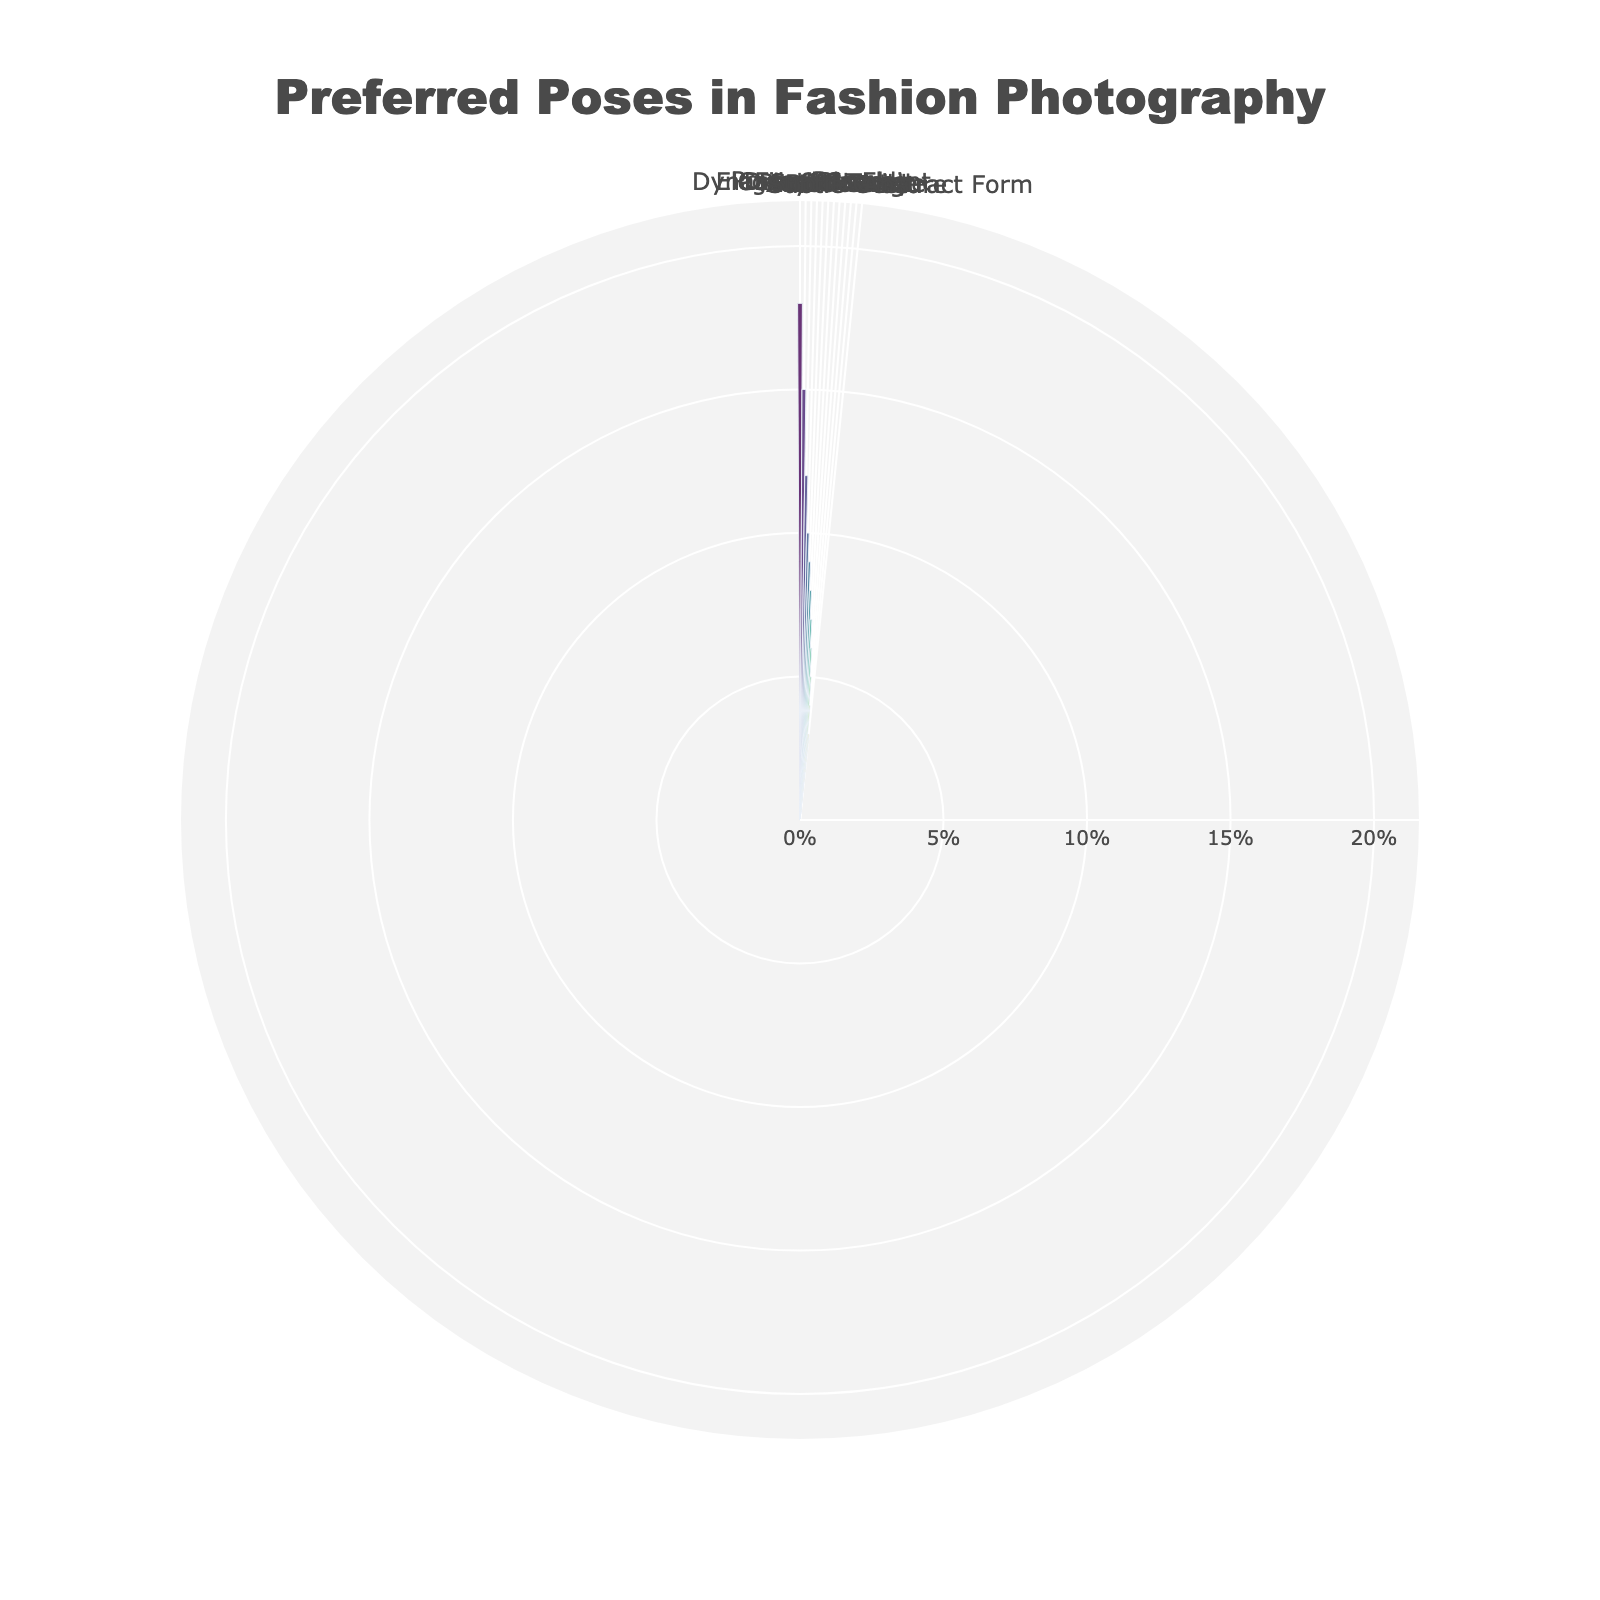Which pose has the highest preference in fashion photography? The figure shows the percentage values of different poses, with "Power Pose" having the highest value at 18%.
Answer: Power Pose What is the total percentage of poses categorized as "artistic" and "abstract"? The "Artistic Angle" has a percentage of 5%, and "Abstract Form" has a percentage of 3%. Summing them up gives 5% + 3% = 8%.
Answer: 8% How does the preference for "Elegant Glance" compare to "Soft Beauty"? The percentages for "Elegant Glance" and "Soft Beauty" are 15% and 6%, respectively. "Elegant Glance" is higher with a difference of 15% - 6% = 9%.
Answer: Elegant Glance Which pose category has the lowest preference, and what is its percentage? The figure shows that "Subtle Gesture" and "Abstract Form" are both at the lowest percentage of 3%.
Answer: Subtle Gesture and Abstract Form What is the average percentage of the four least preferred poses? The four least preferred poses are "Bold Stride" (4%), "Subtle Gesture" (3%), "Abstract Form" (3%), and "Artistic Angle" (5%). Sum them up to get 4% + 3% + 3% + 5% = 15%, and then divide by 4 to get the average, 15% / 4 = 3.75%.
Answer: 3.75% Which pose is preferred almost twice as much as "Bold Stride"? The percentage for "Bold Stride" is 4%. "Elegant Glance" has a percentage of 15%, which is almost four times more, and "Dynamic Movement" has a percentage of 12%, which is three times more. "Casual Stand" has a percentage of 10%, which is about twice as much as 4%.
Answer: Casual Stand How do "Dynamic Movement" and "Playful Twist" together compare with "Power Pose"? "Dynamic Movement" has a percentage of 12%, and "Playful Twist" has a percentage of 7%. Adding them together results in 12% + 7% = 19%. "Power Pose" stands at 18%, so together they are slightly higher.
Answer: 19% vs 18% What is the median percentage value of all the poses? To find the median, order the poses by percentage: 3%, 3%, 4%, 5%, 6%, 7%, 8%, 9%, 10%, 12%, 15%, 18%. The middle values are 7% and 8%, so the median is (7% + 8%) / 2 = 7.5%.
Answer: 7.5% Which pose categories make up more than 50% of the total preference in fashion photography? Adding up the percentages from highest to determine where we surpass 50%: "Power Pose" (18%), "Elegant Glance" (15%), "Dynamic Movement" (12%), and "Casual Stand" (10%). Their cumulative percentage is 55%.
Answer: Power Pose, Elegant Glance, Dynamic Movement, Casual Stand 